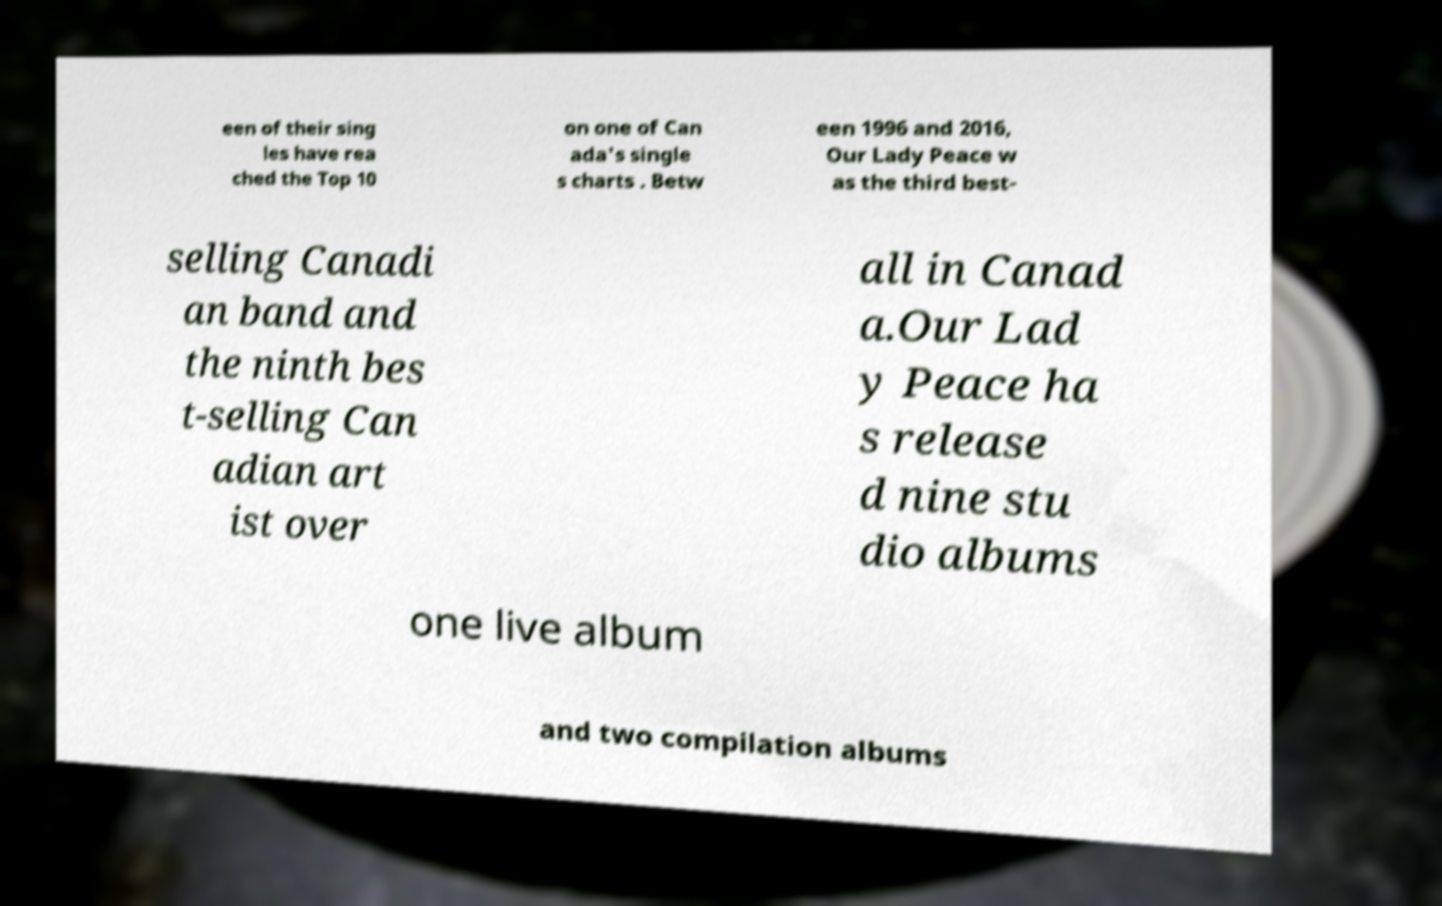Please identify and transcribe the text found in this image. een of their sing les have rea ched the Top 10 on one of Can ada's single s charts . Betw een 1996 and 2016, Our Lady Peace w as the third best- selling Canadi an band and the ninth bes t-selling Can adian art ist over all in Canad a.Our Lad y Peace ha s release d nine stu dio albums one live album and two compilation albums 